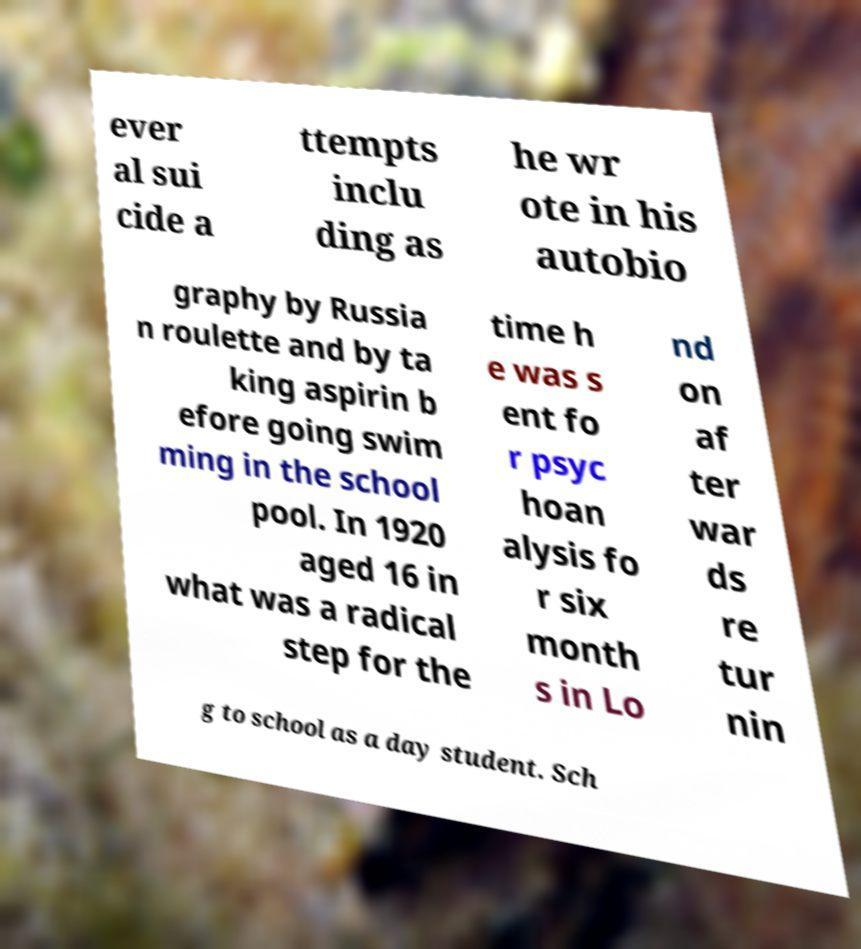Could you extract and type out the text from this image? ever al sui cide a ttempts inclu ding as he wr ote in his autobio graphy by Russia n roulette and by ta king aspirin b efore going swim ming in the school pool. In 1920 aged 16 in what was a radical step for the time h e was s ent fo r psyc hoan alysis fo r six month s in Lo nd on af ter war ds re tur nin g to school as a day student. Sch 